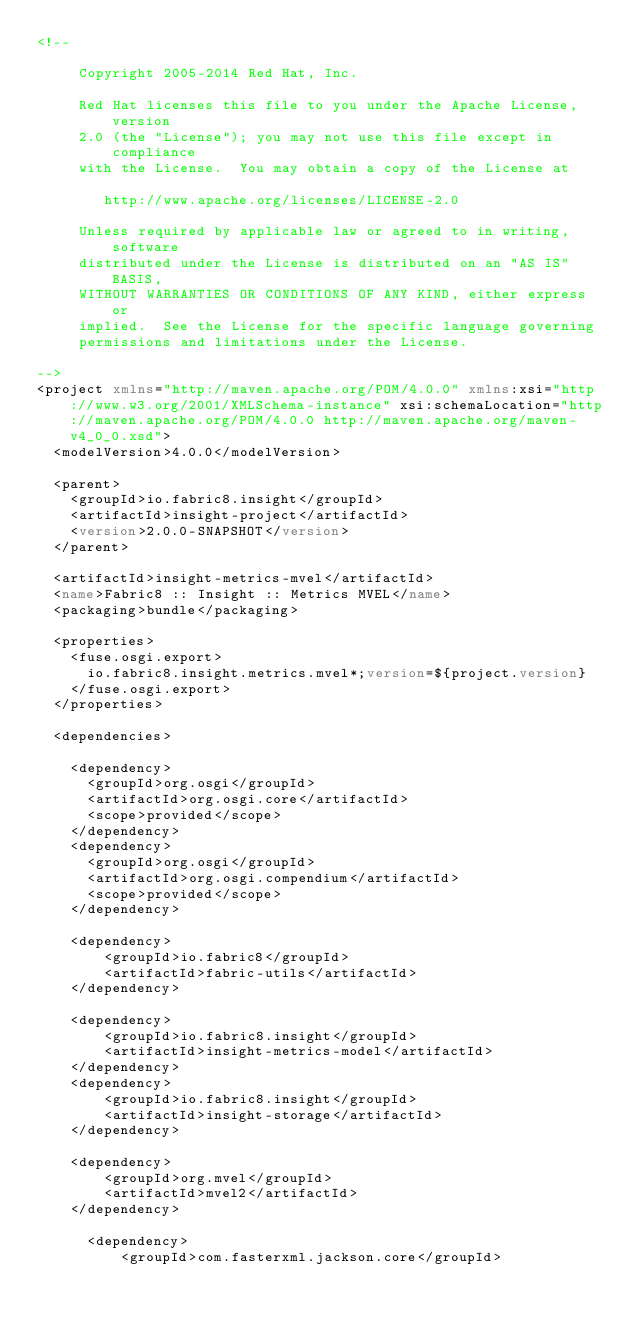<code> <loc_0><loc_0><loc_500><loc_500><_XML_><!--

     Copyright 2005-2014 Red Hat, Inc.

     Red Hat licenses this file to you under the Apache License, version
     2.0 (the "License"); you may not use this file except in compliance
     with the License.  You may obtain a copy of the License at

        http://www.apache.org/licenses/LICENSE-2.0

     Unless required by applicable law or agreed to in writing, software
     distributed under the License is distributed on an "AS IS" BASIS,
     WITHOUT WARRANTIES OR CONDITIONS OF ANY KIND, either express or
     implied.  See the License for the specific language governing
     permissions and limitations under the License.

-->
<project xmlns="http://maven.apache.org/POM/4.0.0" xmlns:xsi="http://www.w3.org/2001/XMLSchema-instance" xsi:schemaLocation="http://maven.apache.org/POM/4.0.0 http://maven.apache.org/maven-v4_0_0.xsd">
  <modelVersion>4.0.0</modelVersion>

  <parent>
    <groupId>io.fabric8.insight</groupId>
    <artifactId>insight-project</artifactId>
    <version>2.0.0-SNAPSHOT</version>
  </parent>

  <artifactId>insight-metrics-mvel</artifactId>
  <name>Fabric8 :: Insight :: Metrics MVEL</name>
  <packaging>bundle</packaging>

  <properties>
    <fuse.osgi.export>
      io.fabric8.insight.metrics.mvel*;version=${project.version}
    </fuse.osgi.export>
  </properties>

  <dependencies>

    <dependency>
      <groupId>org.osgi</groupId>
      <artifactId>org.osgi.core</artifactId>
      <scope>provided</scope>
    </dependency>
    <dependency>
      <groupId>org.osgi</groupId>
      <artifactId>org.osgi.compendium</artifactId>
      <scope>provided</scope>
    </dependency>

    <dependency>
        <groupId>io.fabric8</groupId>
        <artifactId>fabric-utils</artifactId>
    </dependency>

    <dependency>
        <groupId>io.fabric8.insight</groupId>
        <artifactId>insight-metrics-model</artifactId>
    </dependency>
    <dependency>
        <groupId>io.fabric8.insight</groupId>
        <artifactId>insight-storage</artifactId>
    </dependency>

    <dependency>
        <groupId>org.mvel</groupId>
        <artifactId>mvel2</artifactId>
    </dependency>

      <dependency>
          <groupId>com.fasterxml.jackson.core</groupId></code> 